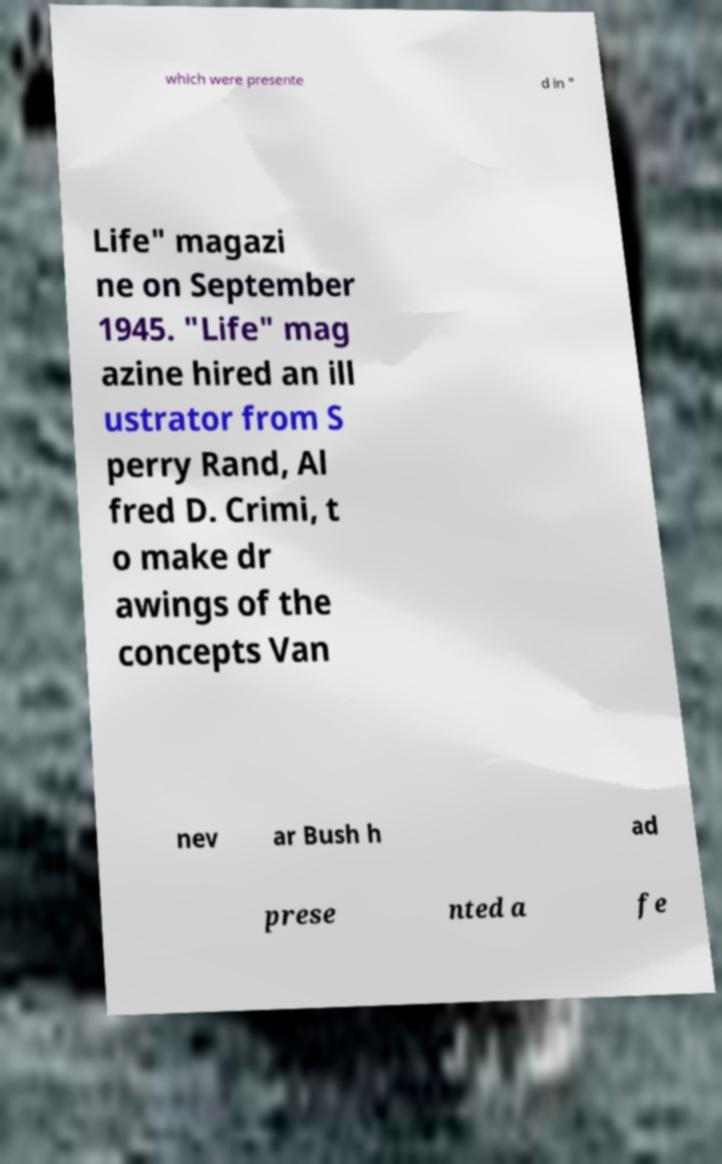For documentation purposes, I need the text within this image transcribed. Could you provide that? which were presente d in " Life" magazi ne on September 1945. "Life" mag azine hired an ill ustrator from S perry Rand, Al fred D. Crimi, t o make dr awings of the concepts Van nev ar Bush h ad prese nted a fe 